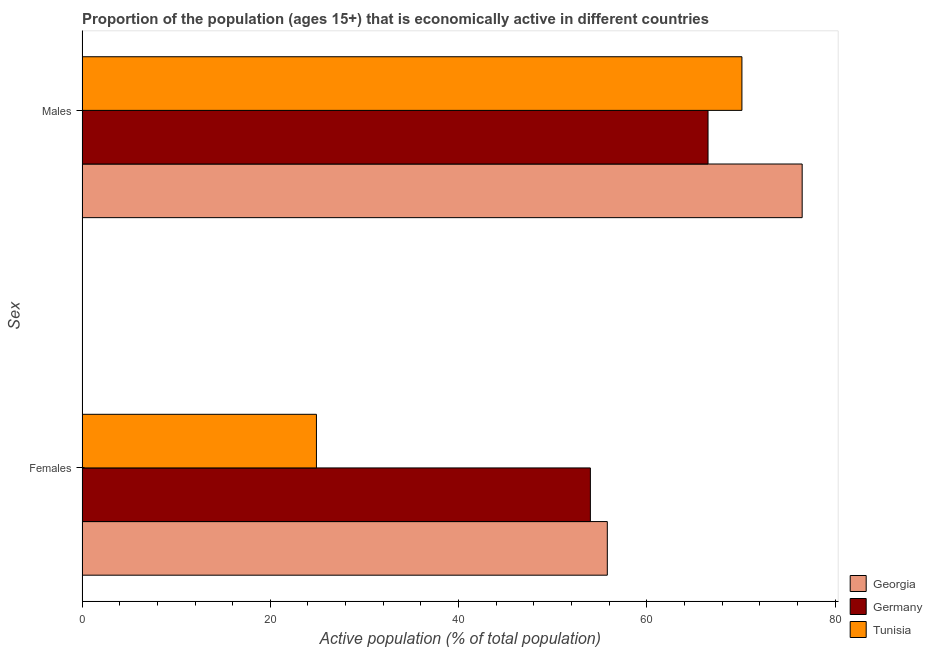How many groups of bars are there?
Ensure brevity in your answer.  2. Are the number of bars per tick equal to the number of legend labels?
Your response must be concise. Yes. How many bars are there on the 1st tick from the bottom?
Your response must be concise. 3. What is the label of the 2nd group of bars from the top?
Make the answer very short. Females. Across all countries, what is the maximum percentage of economically active male population?
Your answer should be compact. 76.5. Across all countries, what is the minimum percentage of economically active male population?
Give a very brief answer. 66.5. In which country was the percentage of economically active male population maximum?
Give a very brief answer. Georgia. In which country was the percentage of economically active male population minimum?
Make the answer very short. Germany. What is the total percentage of economically active male population in the graph?
Ensure brevity in your answer.  213.1. What is the difference between the percentage of economically active female population in Germany and that in Tunisia?
Provide a short and direct response. 29.1. What is the difference between the percentage of economically active male population in Tunisia and the percentage of economically active female population in Georgia?
Make the answer very short. 14.3. What is the average percentage of economically active female population per country?
Ensure brevity in your answer.  44.9. What is the ratio of the percentage of economically active male population in Tunisia to that in Germany?
Give a very brief answer. 1.05. Is the percentage of economically active male population in Tunisia less than that in Georgia?
Your answer should be compact. Yes. In how many countries, is the percentage of economically active male population greater than the average percentage of economically active male population taken over all countries?
Provide a short and direct response. 1. What does the 2nd bar from the top in Females represents?
Make the answer very short. Germany. What does the 1st bar from the bottom in Males represents?
Ensure brevity in your answer.  Georgia. How many bars are there?
Make the answer very short. 6. Are all the bars in the graph horizontal?
Make the answer very short. Yes. How many countries are there in the graph?
Offer a terse response. 3. What is the difference between two consecutive major ticks on the X-axis?
Provide a succinct answer. 20. Does the graph contain grids?
Your answer should be very brief. No. How are the legend labels stacked?
Give a very brief answer. Vertical. What is the title of the graph?
Your answer should be compact. Proportion of the population (ages 15+) that is economically active in different countries. Does "Grenada" appear as one of the legend labels in the graph?
Your response must be concise. No. What is the label or title of the X-axis?
Offer a very short reply. Active population (% of total population). What is the label or title of the Y-axis?
Provide a short and direct response. Sex. What is the Active population (% of total population) in Georgia in Females?
Provide a succinct answer. 55.8. What is the Active population (% of total population) in Germany in Females?
Your answer should be very brief. 54. What is the Active population (% of total population) in Tunisia in Females?
Provide a succinct answer. 24.9. What is the Active population (% of total population) in Georgia in Males?
Offer a terse response. 76.5. What is the Active population (% of total population) of Germany in Males?
Keep it short and to the point. 66.5. What is the Active population (% of total population) in Tunisia in Males?
Offer a very short reply. 70.1. Across all Sex, what is the maximum Active population (% of total population) of Georgia?
Offer a terse response. 76.5. Across all Sex, what is the maximum Active population (% of total population) in Germany?
Give a very brief answer. 66.5. Across all Sex, what is the maximum Active population (% of total population) of Tunisia?
Your response must be concise. 70.1. Across all Sex, what is the minimum Active population (% of total population) in Georgia?
Offer a terse response. 55.8. Across all Sex, what is the minimum Active population (% of total population) in Germany?
Offer a very short reply. 54. Across all Sex, what is the minimum Active population (% of total population) in Tunisia?
Your answer should be compact. 24.9. What is the total Active population (% of total population) in Georgia in the graph?
Give a very brief answer. 132.3. What is the total Active population (% of total population) of Germany in the graph?
Your response must be concise. 120.5. What is the difference between the Active population (% of total population) in Georgia in Females and that in Males?
Provide a succinct answer. -20.7. What is the difference between the Active population (% of total population) in Tunisia in Females and that in Males?
Keep it short and to the point. -45.2. What is the difference between the Active population (% of total population) of Georgia in Females and the Active population (% of total population) of Germany in Males?
Keep it short and to the point. -10.7. What is the difference between the Active population (% of total population) of Georgia in Females and the Active population (% of total population) of Tunisia in Males?
Your answer should be compact. -14.3. What is the difference between the Active population (% of total population) in Germany in Females and the Active population (% of total population) in Tunisia in Males?
Give a very brief answer. -16.1. What is the average Active population (% of total population) in Georgia per Sex?
Your answer should be very brief. 66.15. What is the average Active population (% of total population) of Germany per Sex?
Offer a very short reply. 60.25. What is the average Active population (% of total population) in Tunisia per Sex?
Ensure brevity in your answer.  47.5. What is the difference between the Active population (% of total population) of Georgia and Active population (% of total population) of Tunisia in Females?
Offer a terse response. 30.9. What is the difference between the Active population (% of total population) of Germany and Active population (% of total population) of Tunisia in Females?
Your answer should be very brief. 29.1. What is the difference between the Active population (% of total population) of Georgia and Active population (% of total population) of Tunisia in Males?
Your answer should be very brief. 6.4. What is the ratio of the Active population (% of total population) of Georgia in Females to that in Males?
Ensure brevity in your answer.  0.73. What is the ratio of the Active population (% of total population) of Germany in Females to that in Males?
Keep it short and to the point. 0.81. What is the ratio of the Active population (% of total population) in Tunisia in Females to that in Males?
Give a very brief answer. 0.36. What is the difference between the highest and the second highest Active population (% of total population) in Georgia?
Give a very brief answer. 20.7. What is the difference between the highest and the second highest Active population (% of total population) in Tunisia?
Your answer should be very brief. 45.2. What is the difference between the highest and the lowest Active population (% of total population) of Georgia?
Your response must be concise. 20.7. What is the difference between the highest and the lowest Active population (% of total population) of Germany?
Your response must be concise. 12.5. What is the difference between the highest and the lowest Active population (% of total population) in Tunisia?
Offer a very short reply. 45.2. 